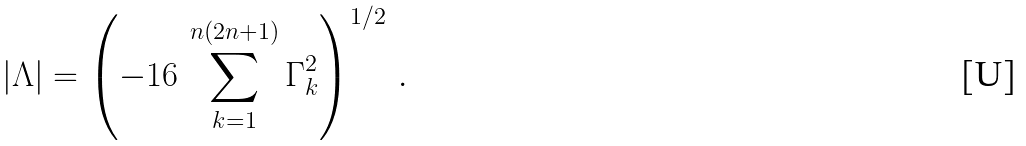Convert formula to latex. <formula><loc_0><loc_0><loc_500><loc_500>| \Lambda | = \left ( - 1 6 \, \sum ^ { n ( 2 n + 1 ) } _ { k = 1 } \Gamma ^ { 2 } _ { k } \right ) ^ { 1 / 2 } \, .</formula> 